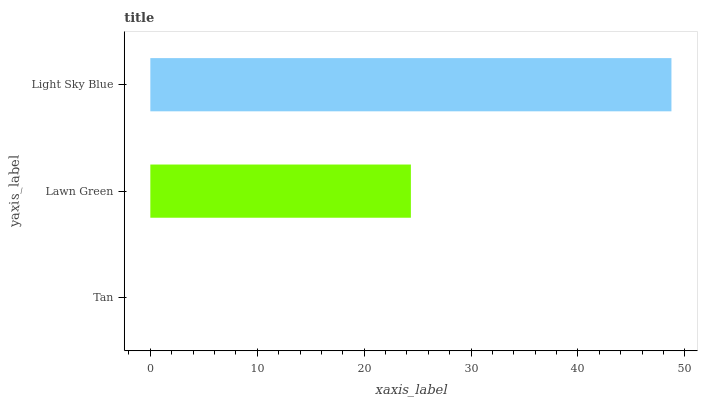Is Tan the minimum?
Answer yes or no. Yes. Is Light Sky Blue the maximum?
Answer yes or no. Yes. Is Lawn Green the minimum?
Answer yes or no. No. Is Lawn Green the maximum?
Answer yes or no. No. Is Lawn Green greater than Tan?
Answer yes or no. Yes. Is Tan less than Lawn Green?
Answer yes or no. Yes. Is Tan greater than Lawn Green?
Answer yes or no. No. Is Lawn Green less than Tan?
Answer yes or no. No. Is Lawn Green the high median?
Answer yes or no. Yes. Is Lawn Green the low median?
Answer yes or no. Yes. Is Light Sky Blue the high median?
Answer yes or no. No. Is Light Sky Blue the low median?
Answer yes or no. No. 